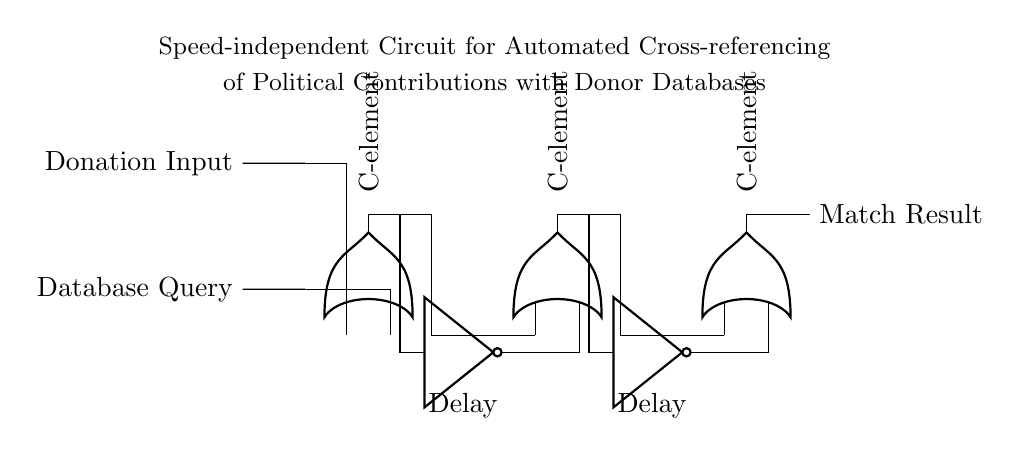What type of circuit is shown? The circuit shown is a speed-independent circuit, which means it operates without dependence on specific timing or clock signals, utilizing asynchronous techniques.
Answer: Speed-independent circuit How many C-elements are present? The circuit contains three C-elements, as indicated by the three vertical blocks labeled in the diagram.
Answer: Three What connects the donation input to the first C-element? The donation input is connected to the first C-element via a short line, which is indicated as a direct connection in the circuit diagram.
Answer: A short line What is the purpose of the delay elements in this circuit? The delay elements introduce necessary timing adjustments in the signal paths, ensuring that all signals are synchronized properly despite being asynchronous.
Answer: Synchronization What is the output of the last C-element? The last C-element outputs the match result, which indicates whether the donation input matches records in the donor database.
Answer: Match result How many inputs does each C-element have? Each C-element has two inputs, as shown by the two labeled input ports on the C-element blocks in the circuit diagram.
Answer: Two 